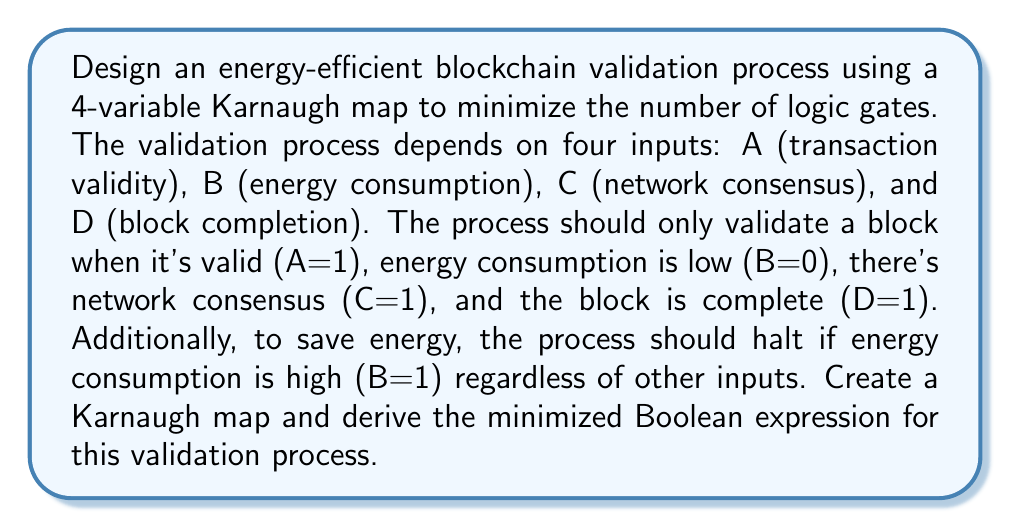Provide a solution to this math problem. Step 1: Create the truth table for the given conditions.
- Output is 1 when A=1, B=0, C=1, D=1
- Output is 0 when B=1 (regardless of other inputs)
- Output is 0 for all other combinations

Step 2: Fill in the 4-variable Karnaugh map based on the truth table.

[asy]
unitsize(1cm);
draw((0,0)--(4,0)--(4,4)--(0,4)--cycle);
draw((0,1)--(4,1));
draw((0,2)--(4,2));
draw((0,3)--(4,3));
draw((1,0)--(1,4));
draw((2,0)--(2,4));
draw((3,0)--(3,4));
label("CD\AB", (0,4.3));
label("00", (0.5,3.5)); label("01", (1.5,3.5)); label("11", (2.5,3.5)); label("10", (3.5,3.5));
label("00", (-0.5,3.5)); label("01", (-0.5,2.5)); label("11", (-0.5,1.5)); label("10", (-0.5,0.5));
label("0", (0.5,2.5)); label("0", (1.5,2.5)); label("0", (2.5,2.5)); label("0", (3.5,2.5));
label("0", (0.5,1.5)); label("0", (1.5,1.5)); label("0", (2.5,1.5)); label("0", (3.5,1.5));
label("0", (0.5,0.5)); label("0", (1.5,0.5)); label("1", (2.5,0.5)); label("0", (3.5,0.5));
[/asy]

Step 3: Identify the largest group of 1's. In this case, there's only one 1 in the map.

Step 4: Write the Boolean expression for the grouped 1:
$$F = A \cdot \overline{B} \cdot C \cdot D$$

Step 5: Verify that this expression satisfies the condition for B=1:
When B=1, $\overline{B}=0$, so the entire expression will be 0, regardless of other inputs.

The minimized Boolean expression is already in its simplest form, as it represents a single minterm.
Answer: $$F = A \cdot \overline{B} \cdot C \cdot D$$ 